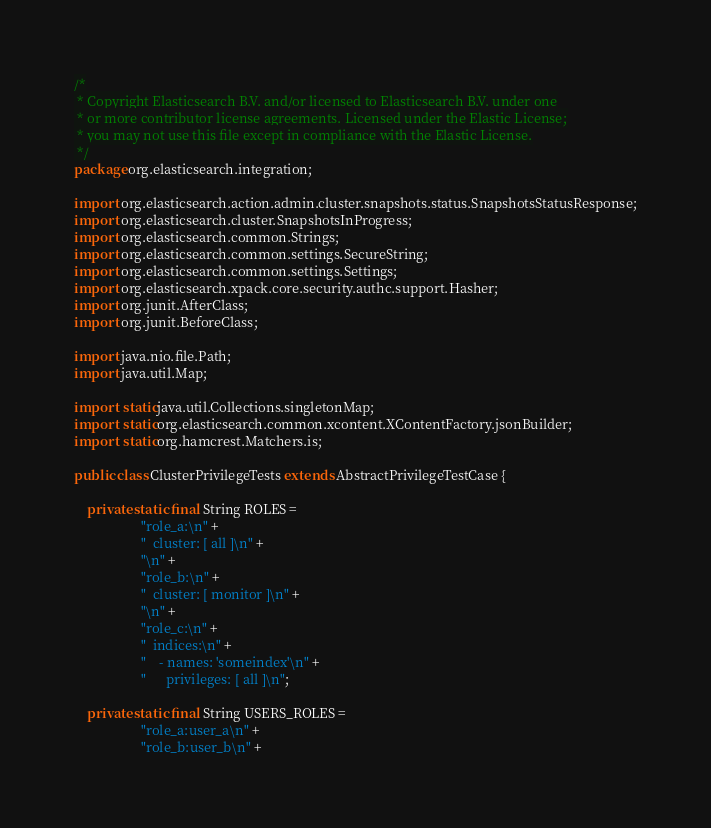Convert code to text. <code><loc_0><loc_0><loc_500><loc_500><_Java_>/*
 * Copyright Elasticsearch B.V. and/or licensed to Elasticsearch B.V. under one
 * or more contributor license agreements. Licensed under the Elastic License;
 * you may not use this file except in compliance with the Elastic License.
 */
package org.elasticsearch.integration;

import org.elasticsearch.action.admin.cluster.snapshots.status.SnapshotsStatusResponse;
import org.elasticsearch.cluster.SnapshotsInProgress;
import org.elasticsearch.common.Strings;
import org.elasticsearch.common.settings.SecureString;
import org.elasticsearch.common.settings.Settings;
import org.elasticsearch.xpack.core.security.authc.support.Hasher;
import org.junit.AfterClass;
import org.junit.BeforeClass;

import java.nio.file.Path;
import java.util.Map;

import static java.util.Collections.singletonMap;
import static org.elasticsearch.common.xcontent.XContentFactory.jsonBuilder;
import static org.hamcrest.Matchers.is;

public class ClusterPrivilegeTests extends AbstractPrivilegeTestCase {

    private static final String ROLES =
                    "role_a:\n" +
                    "  cluster: [ all ]\n" +
                    "\n" +
                    "role_b:\n" +
                    "  cluster: [ monitor ]\n" +
                    "\n" +
                    "role_c:\n" +
                    "  indices:\n" +
                    "    - names: 'someindex'\n" +
                    "      privileges: [ all ]\n";

    private static final String USERS_ROLES =
                    "role_a:user_a\n" +
                    "role_b:user_b\n" +</code> 